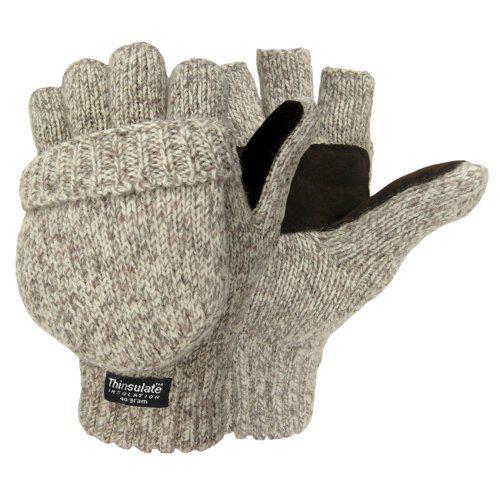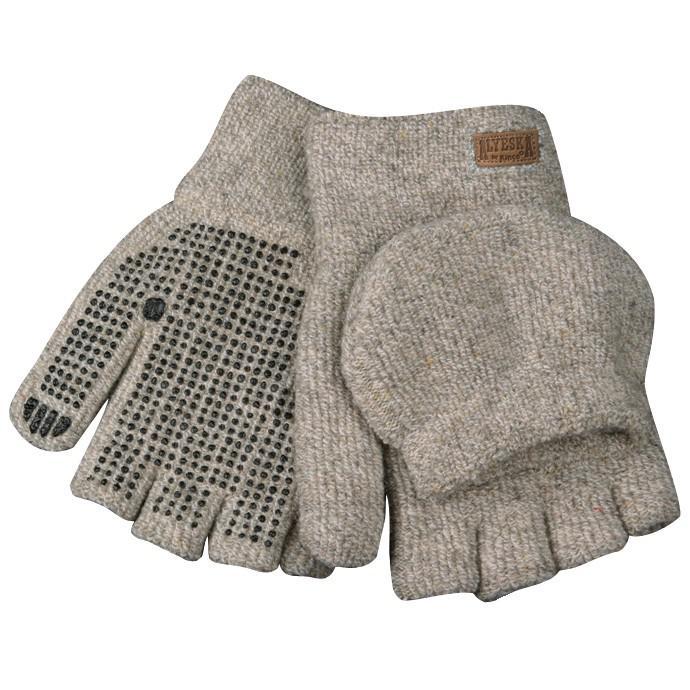The first image is the image on the left, the second image is the image on the right. For the images shown, is this caption "The image contains fingerless mittens/gloves." true? Answer yes or no. Yes. The first image is the image on the left, the second image is the image on the right. Given the left and right images, does the statement "There is at least one pair of convertible fingerless gloves." hold true? Answer yes or no. Yes. 